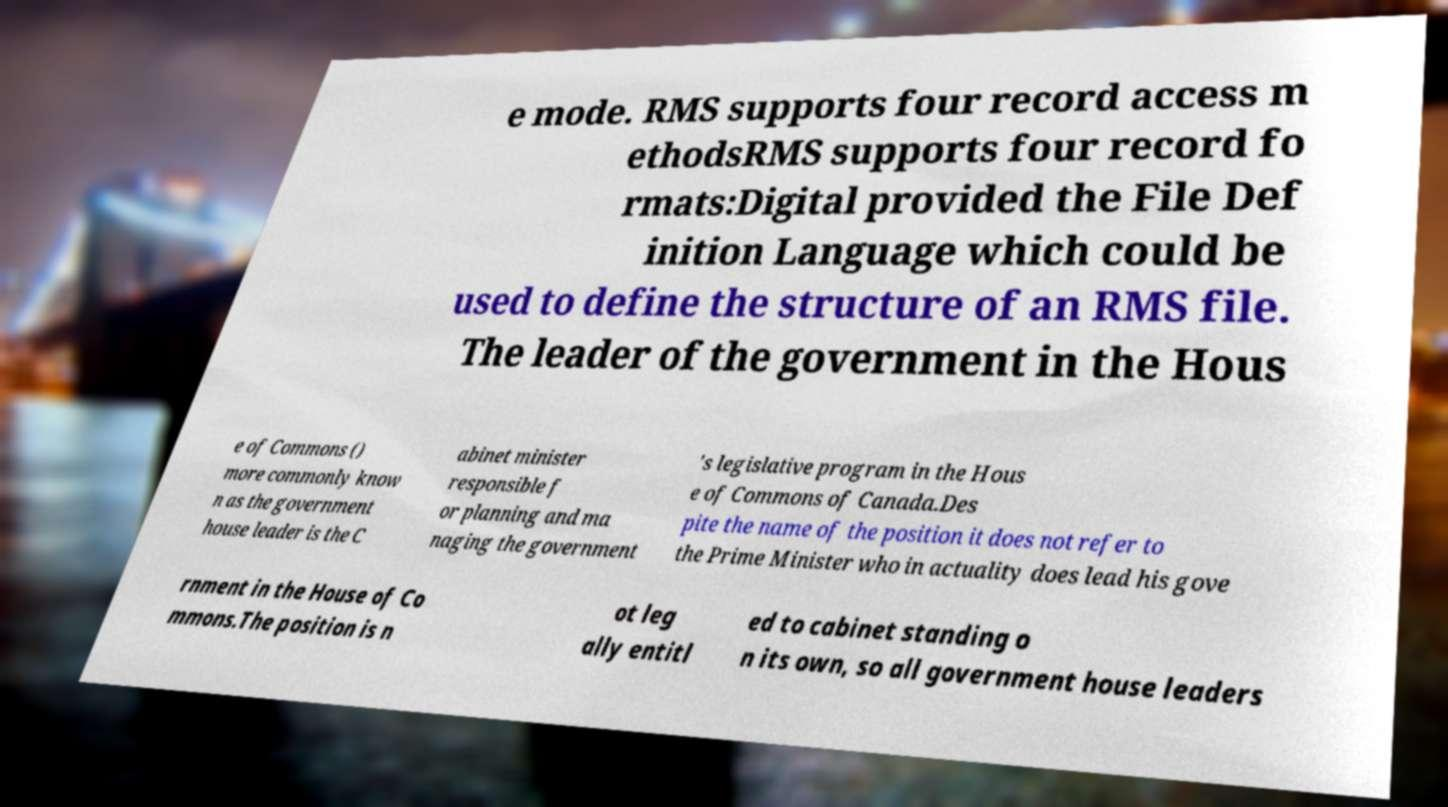I need the written content from this picture converted into text. Can you do that? e mode. RMS supports four record access m ethodsRMS supports four record fo rmats:Digital provided the File Def inition Language which could be used to define the structure of an RMS file. The leader of the government in the Hous e of Commons () more commonly know n as the government house leader is the C abinet minister responsible f or planning and ma naging the government 's legislative program in the Hous e of Commons of Canada.Des pite the name of the position it does not refer to the Prime Minister who in actuality does lead his gove rnment in the House of Co mmons.The position is n ot leg ally entitl ed to cabinet standing o n its own, so all government house leaders 